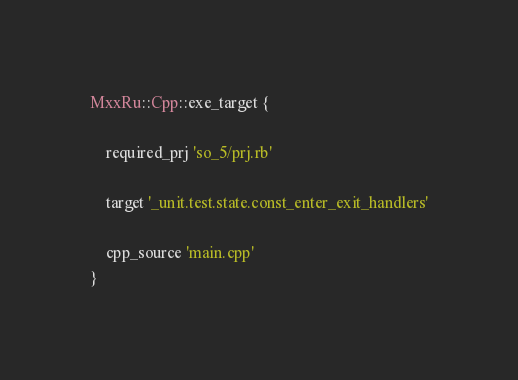Convert code to text. <code><loc_0><loc_0><loc_500><loc_500><_Ruby_>MxxRu::Cpp::exe_target {

	required_prj 'so_5/prj.rb'

	target '_unit.test.state.const_enter_exit_handlers'

	cpp_source 'main.cpp'
}

</code> 